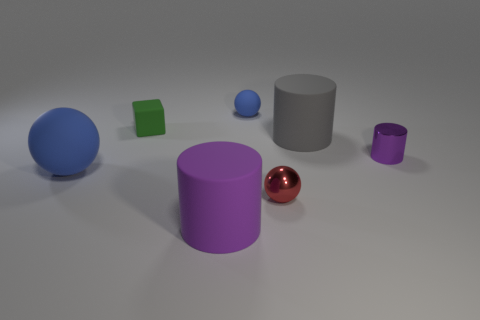There is a rubber cylinder that is right of the purple matte cylinder; what size is it?
Offer a terse response. Large. The red object has what shape?
Offer a terse response. Sphere. Is the size of the purple cylinder that is left of the big gray rubber cylinder the same as the sphere that is behind the tiny purple cylinder?
Offer a terse response. No. What is the size of the purple cylinder in front of the tiny metal object that is behind the large thing to the left of the purple matte cylinder?
Offer a very short reply. Large. What is the shape of the tiny thing that is to the right of the sphere that is in front of the big rubber object that is to the left of the green object?
Provide a short and direct response. Cylinder. There is a big thing to the right of the purple matte cylinder; what shape is it?
Make the answer very short. Cylinder. Does the tiny blue ball have the same material as the sphere that is on the right side of the tiny blue object?
Offer a very short reply. No. What number of other things are the same shape as the green rubber object?
Provide a short and direct response. 0. Do the tiny cylinder and the cylinder that is on the left side of the red object have the same color?
Offer a terse response. Yes. There is a blue object left of the blue rubber object behind the green block; what is its shape?
Keep it short and to the point. Sphere. 